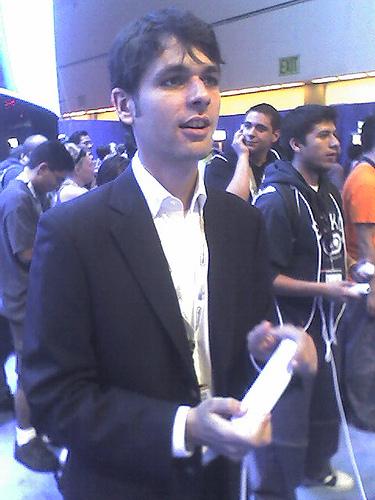Is this person in a crowd?
Quick response, please. Yes. What is the man holding?
Be succinct. Wii controller. Does this person have on a necktie?
Short answer required. No. 